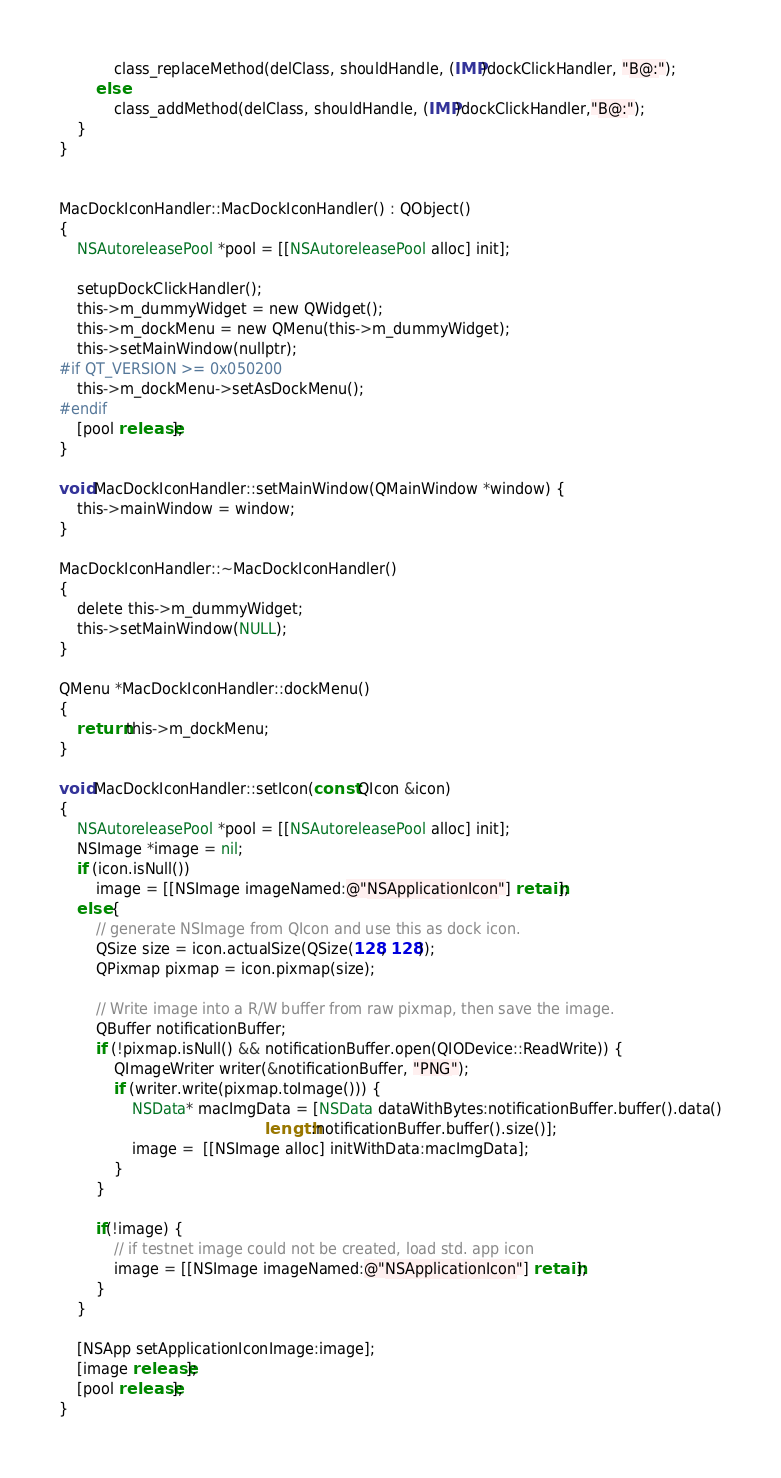<code> <loc_0><loc_0><loc_500><loc_500><_ObjectiveC_>            class_replaceMethod(delClass, shouldHandle, (IMP)dockClickHandler, "B@:");
        else
            class_addMethod(delClass, shouldHandle, (IMP)dockClickHandler,"B@:");
    }
}


MacDockIconHandler::MacDockIconHandler() : QObject()
{
    NSAutoreleasePool *pool = [[NSAutoreleasePool alloc] init];

    setupDockClickHandler();
    this->m_dummyWidget = new QWidget();
    this->m_dockMenu = new QMenu(this->m_dummyWidget);
    this->setMainWindow(nullptr);
#if QT_VERSION >= 0x050200
    this->m_dockMenu->setAsDockMenu();
#endif
    [pool release];
}

void MacDockIconHandler::setMainWindow(QMainWindow *window) {
    this->mainWindow = window;
}

MacDockIconHandler::~MacDockIconHandler()
{
    delete this->m_dummyWidget;
    this->setMainWindow(NULL);
}

QMenu *MacDockIconHandler::dockMenu()
{
    return this->m_dockMenu;
}

void MacDockIconHandler::setIcon(const QIcon &icon)
{
    NSAutoreleasePool *pool = [[NSAutoreleasePool alloc] init];
    NSImage *image = nil;
    if (icon.isNull())
        image = [[NSImage imageNamed:@"NSApplicationIcon"] retain];
    else {
        // generate NSImage from QIcon and use this as dock icon.
        QSize size = icon.actualSize(QSize(128, 128));
        QPixmap pixmap = icon.pixmap(size);

        // Write image into a R/W buffer from raw pixmap, then save the image.
        QBuffer notificationBuffer;
        if (!pixmap.isNull() && notificationBuffer.open(QIODevice::ReadWrite)) {
            QImageWriter writer(&notificationBuffer, "PNG");
            if (writer.write(pixmap.toImage())) {
                NSData* macImgData = [NSData dataWithBytes:notificationBuffer.buffer().data()
                                             length:notificationBuffer.buffer().size()];
                image =  [[NSImage alloc] initWithData:macImgData];
            }
        }

        if(!image) {
            // if testnet image could not be created, load std. app icon
            image = [[NSImage imageNamed:@"NSApplicationIcon"] retain];
        }
    }

    [NSApp setApplicationIconImage:image];
    [image release];
    [pool release];
}
</code> 